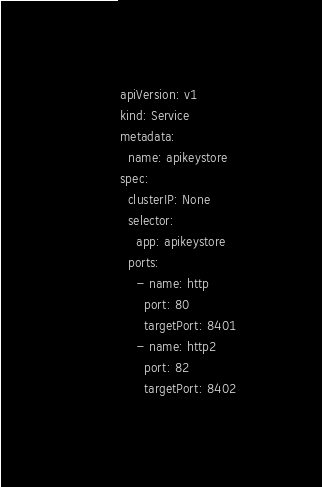Convert code to text. <code><loc_0><loc_0><loc_500><loc_500><_YAML_>apiVersion: v1
kind: Service
metadata:
  name: apikeystore
spec:
  clusterIP: None
  selector:
    app: apikeystore
  ports:
    - name: http
      port: 80
      targetPort: 8401
    - name: http2
      port: 82
      targetPort: 8402

</code> 